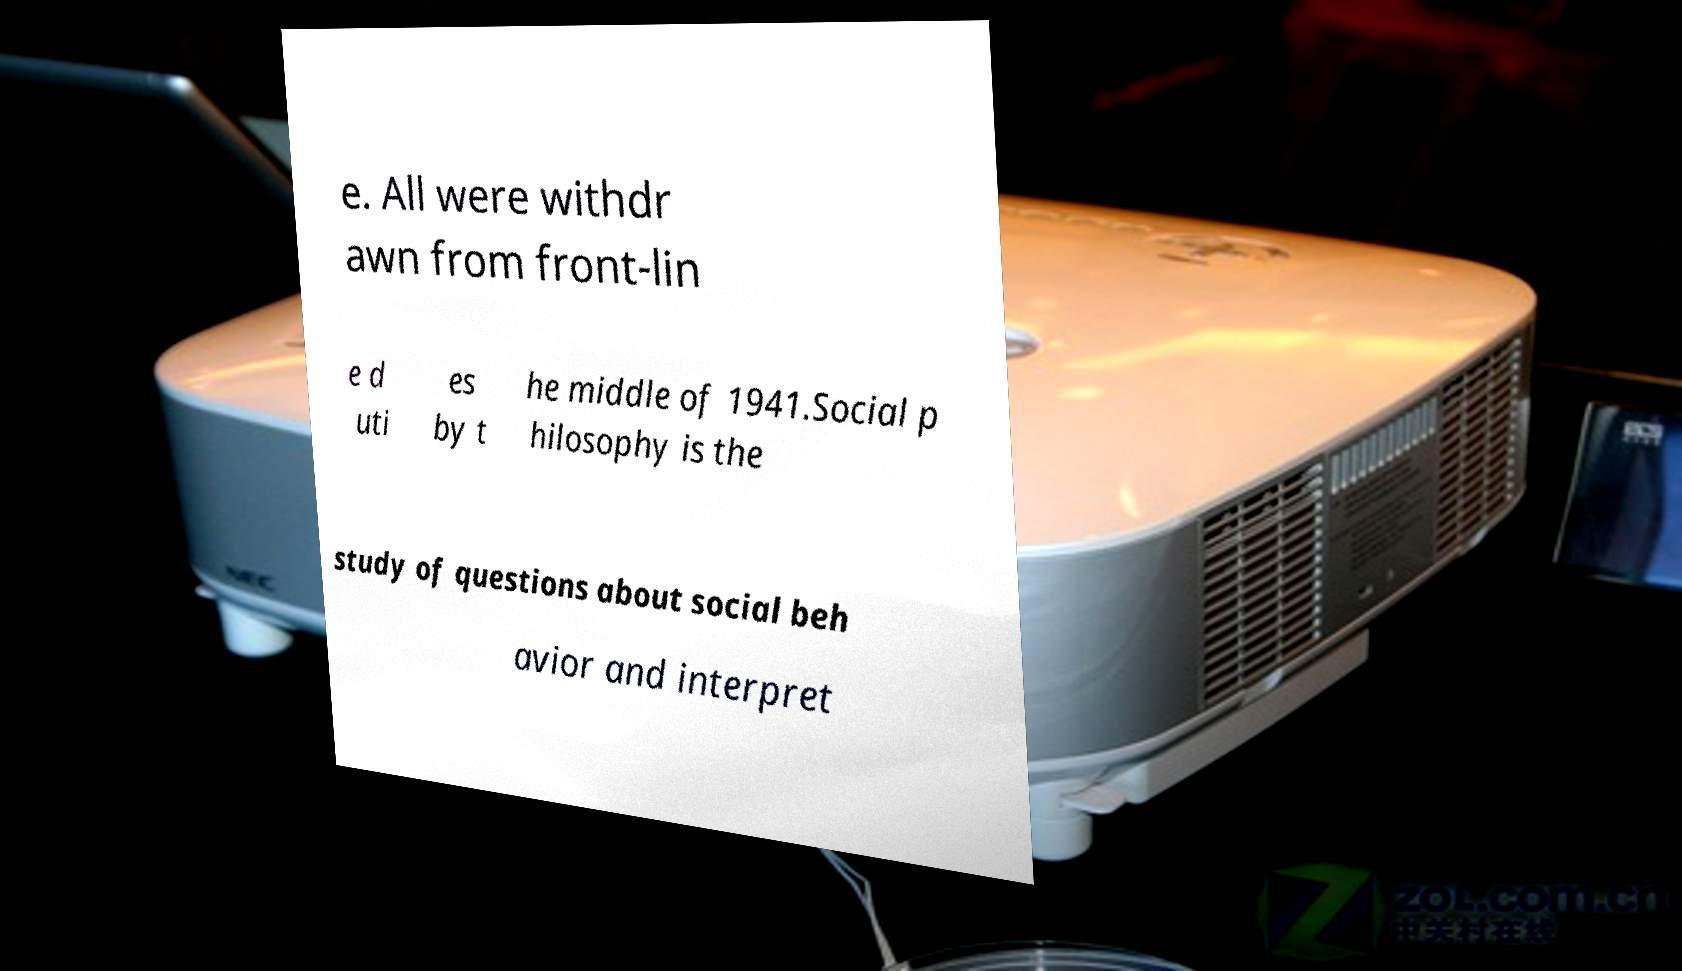Can you accurately transcribe the text from the provided image for me? e. All were withdr awn from front-lin e d uti es by t he middle of 1941.Social p hilosophy is the study of questions about social beh avior and interpret 